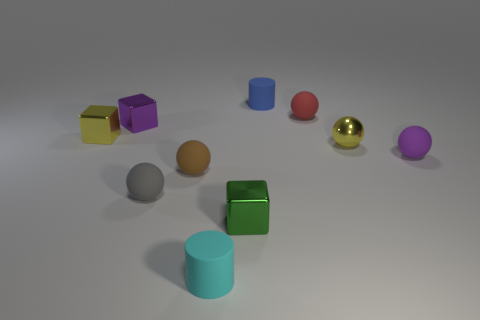What number of small objects have the same material as the small purple ball?
Make the answer very short. 5. There is a red ball; what number of brown balls are behind it?
Offer a terse response. 0. Are the small cylinder in front of the small purple rubber thing and the cylinder that is behind the yellow ball made of the same material?
Provide a short and direct response. Yes. Is the number of small brown balls to the left of the small brown matte object greater than the number of small objects that are behind the green shiny cube?
Make the answer very short. No. What material is the cube that is the same color as the small metallic ball?
Ensure brevity in your answer.  Metal. Is there anything else that has the same shape as the purple metal object?
Provide a succinct answer. Yes. What is the small thing that is both in front of the tiny gray object and behind the cyan matte object made of?
Make the answer very short. Metal. Does the tiny purple cube have the same material as the tiny cylinder in front of the yellow cube?
Your answer should be compact. No. What number of things are either small gray things or small things that are on the right side of the small cyan matte cylinder?
Your answer should be very brief. 6. There is a metal cube behind the small yellow block; is it the same size as the yellow object that is left of the purple cube?
Offer a terse response. Yes. 